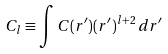Convert formula to latex. <formula><loc_0><loc_0><loc_500><loc_500>C _ { l } \equiv \int C ( r ^ { \prime } ) ( r ^ { \prime } ) ^ { l + 2 } \, d r ^ { \prime }</formula> 